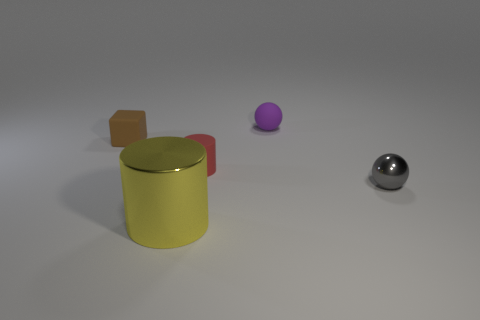Is the color of the small metallic ball the same as the big object? No, the colors are not the same. The small metallic ball has a shiny, reflective silver color, while the large object, which appears to be a cylindrical container, has a matte yellow color with a reflective golden lid. 